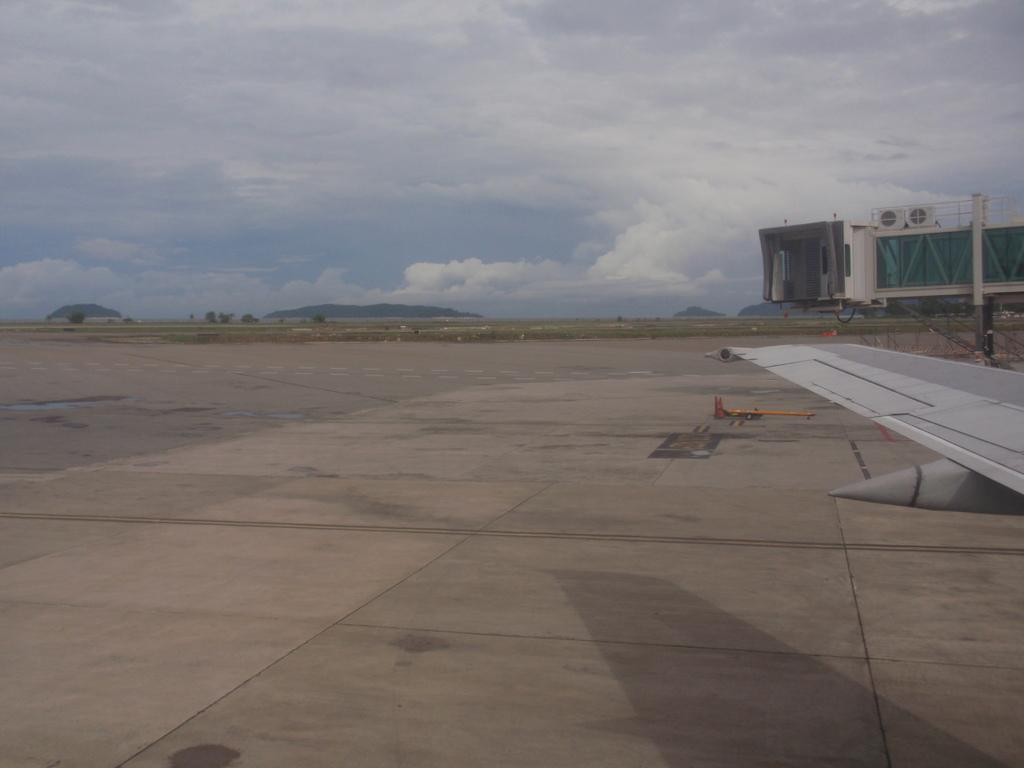What type of location is shown in the image? The image depicts an open area. What can be seen on the right side of the image? There is an airplane wing on the right side of the image. What type of structure is present in the image? There is a building in the image. What is visible at the top of the image? The sky is covered with clouds at the top of the image. What type of stone is used to create the baseball in the image? There is no baseball present in the image, so it is not possible to determine what type of stone might be used to create one. 